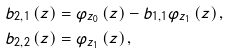Convert formula to latex. <formula><loc_0><loc_0><loc_500><loc_500>b _ { 2 , 1 } \left ( z \right ) & = \varphi _ { z _ { 0 } } \left ( z \right ) - b _ { 1 , 1 } \varphi _ { z _ { 1 } } \left ( z \right ) , \\ b _ { 2 , 2 } \left ( z \right ) & = \varphi _ { z _ { 1 } } \left ( z \right ) ,</formula> 